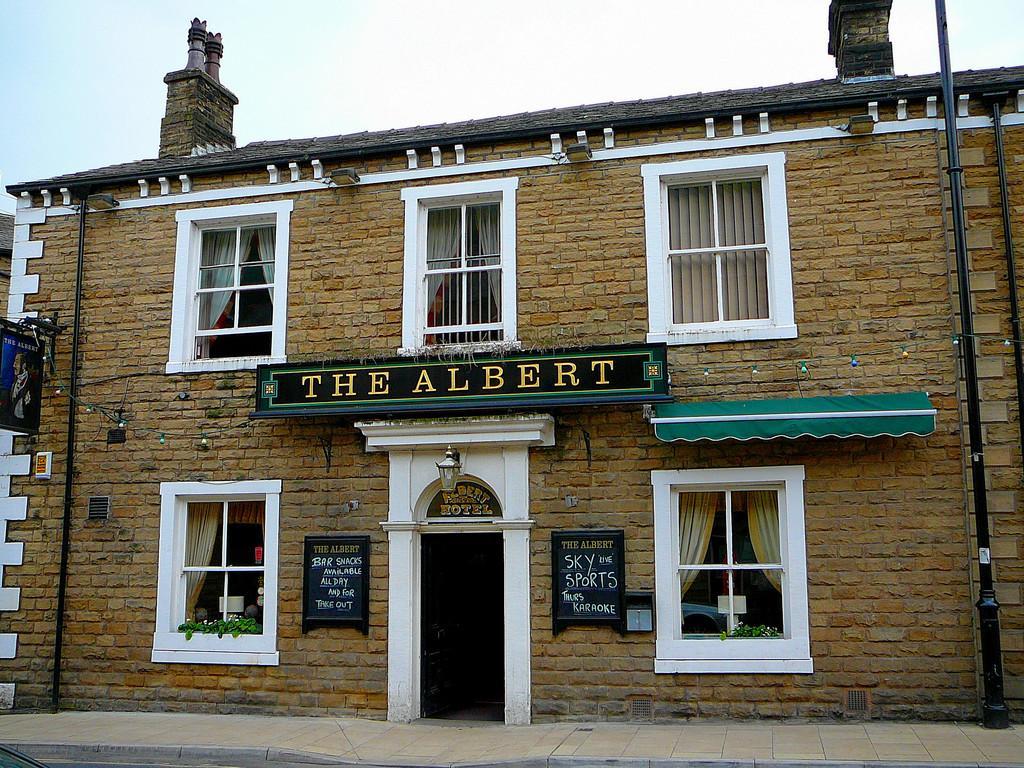Could you give a brief overview of what you see in this image? In the center of the image we can see building. On the building we can see windows, curtains, light and door. In the background there is sky. 